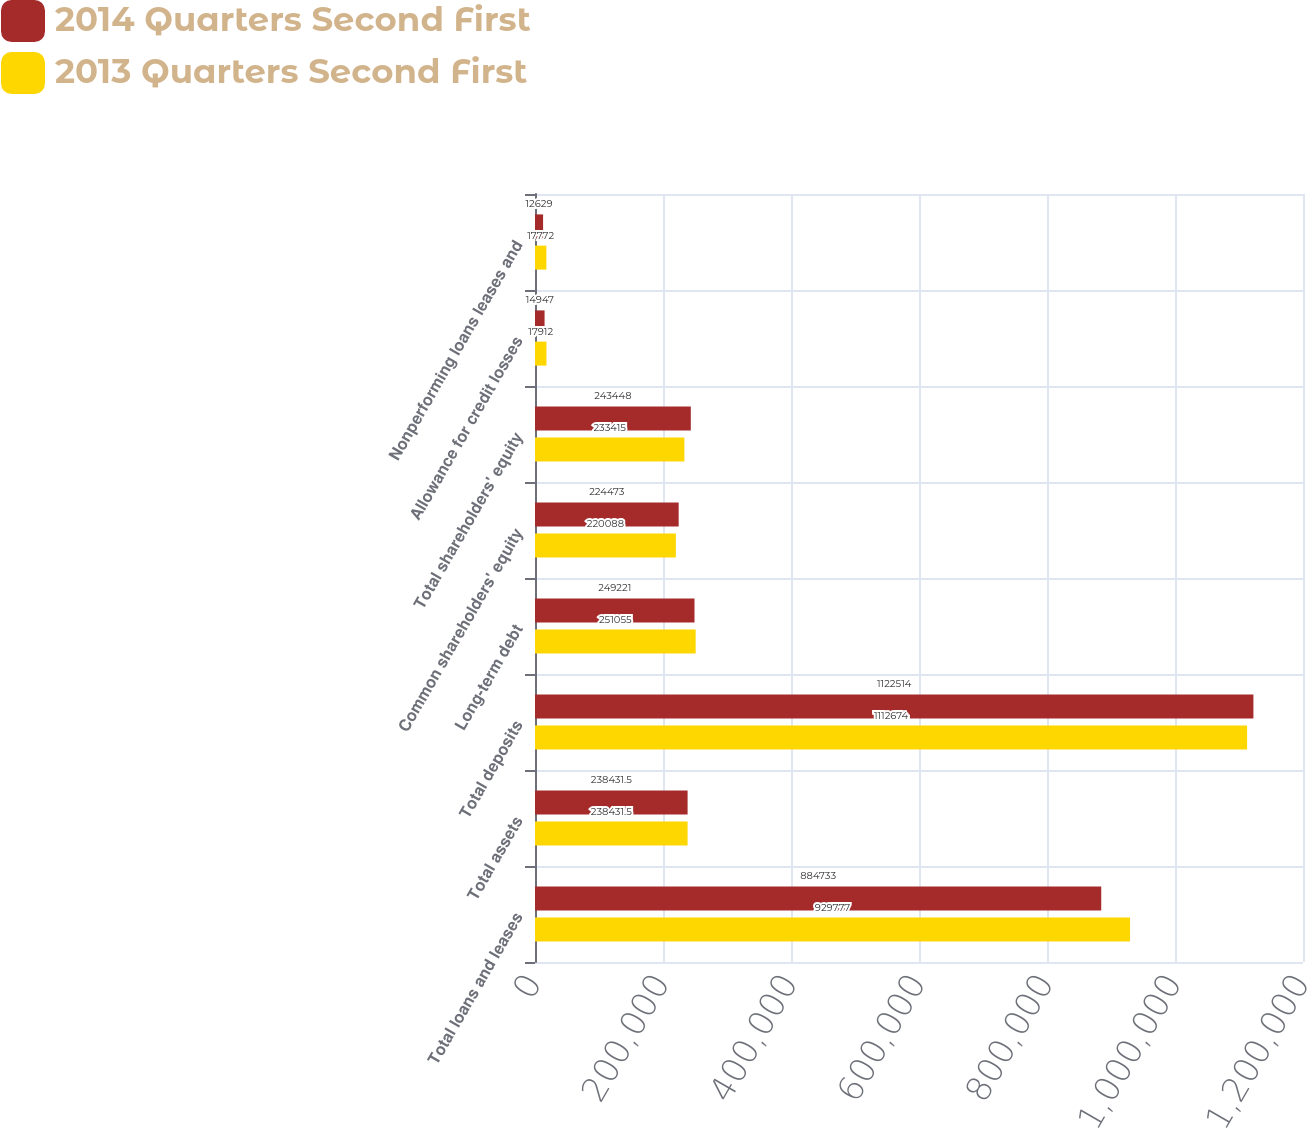Convert chart. <chart><loc_0><loc_0><loc_500><loc_500><stacked_bar_chart><ecel><fcel>Total loans and leases<fcel>Total assets<fcel>Total deposits<fcel>Long-term debt<fcel>Common shareholders' equity<fcel>Total shareholders' equity<fcel>Allowance for credit losses<fcel>Nonperforming loans leases and<nl><fcel>2014 Quarters Second First<fcel>884733<fcel>238432<fcel>1.12251e+06<fcel>249221<fcel>224473<fcel>243448<fcel>14947<fcel>12629<nl><fcel>2013 Quarters Second First<fcel>929777<fcel>238432<fcel>1.11267e+06<fcel>251055<fcel>220088<fcel>233415<fcel>17912<fcel>17772<nl></chart> 